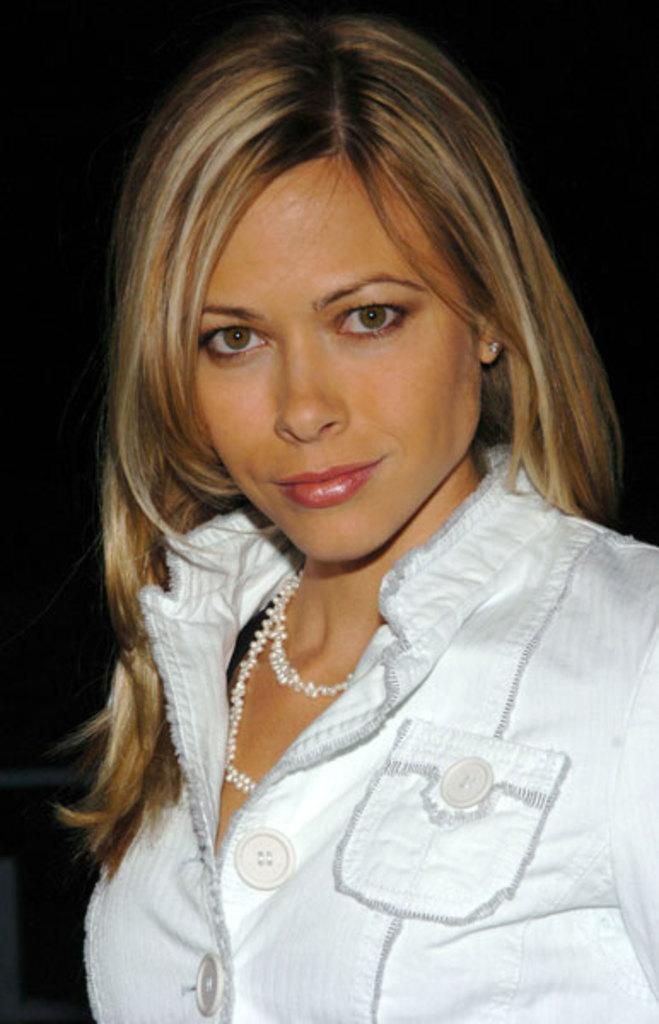Who is the main subject in the image? There is a woman in the image. What is the woman wearing? The woman is wearing white clothes. Are there any accessories visible on the woman? Yes, the woman is wearing a necklace. What can be observed about the background of the image? The background of the image is dark. What type of advertisement can be seen in the image? There is no advertisement present in the image; it features a woman wearing white clothes and a necklace against a dark background. 